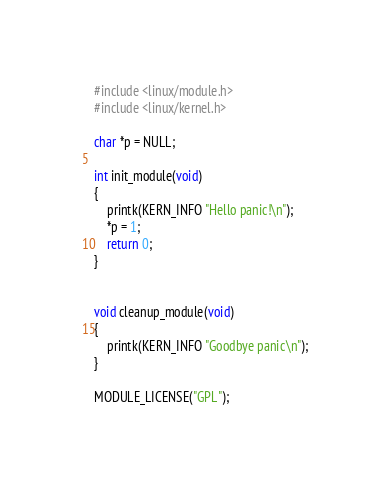Convert code to text. <code><loc_0><loc_0><loc_500><loc_500><_C_>#include <linux/module.h>
#include <linux/kernel.h>

char *p = NULL;

int init_module(void) 
{
	printk(KERN_INFO "Hello panic!\n");
	*p = 1;
	return 0;
}


void cleanup_module(void)
{
	printk(KERN_INFO "Goodbye panic\n");
}

MODULE_LICENSE("GPL");
</code> 